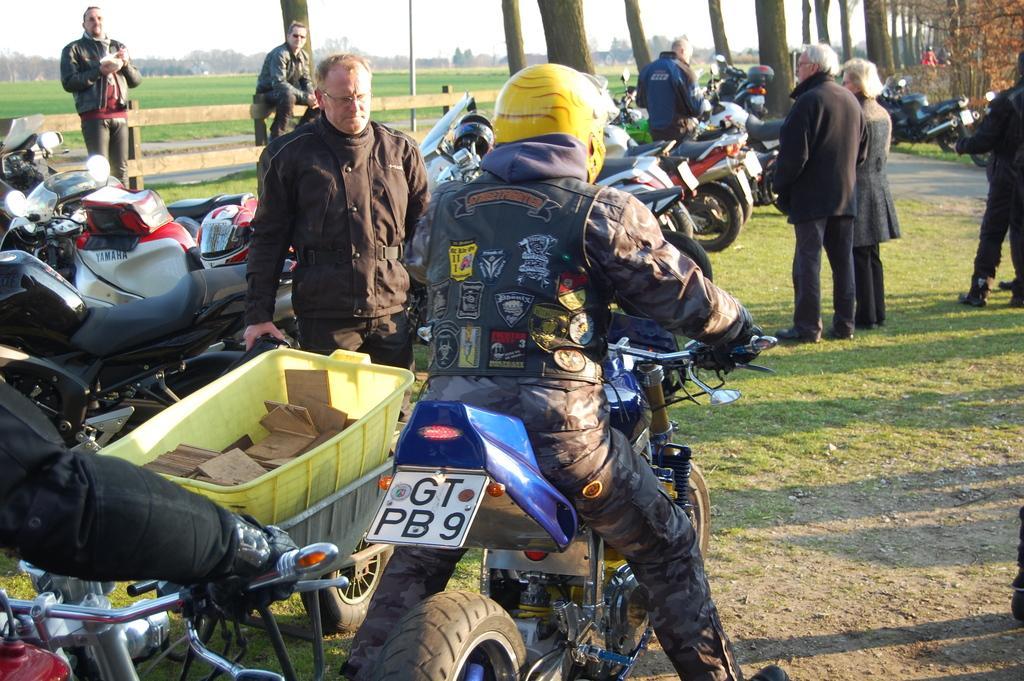In one or two sentences, can you explain what this image depicts? Here is a man wearing helmet and sitting on the motor bike. There are few motorbikes parked. Here are few people standing. These are the trees at the background. 